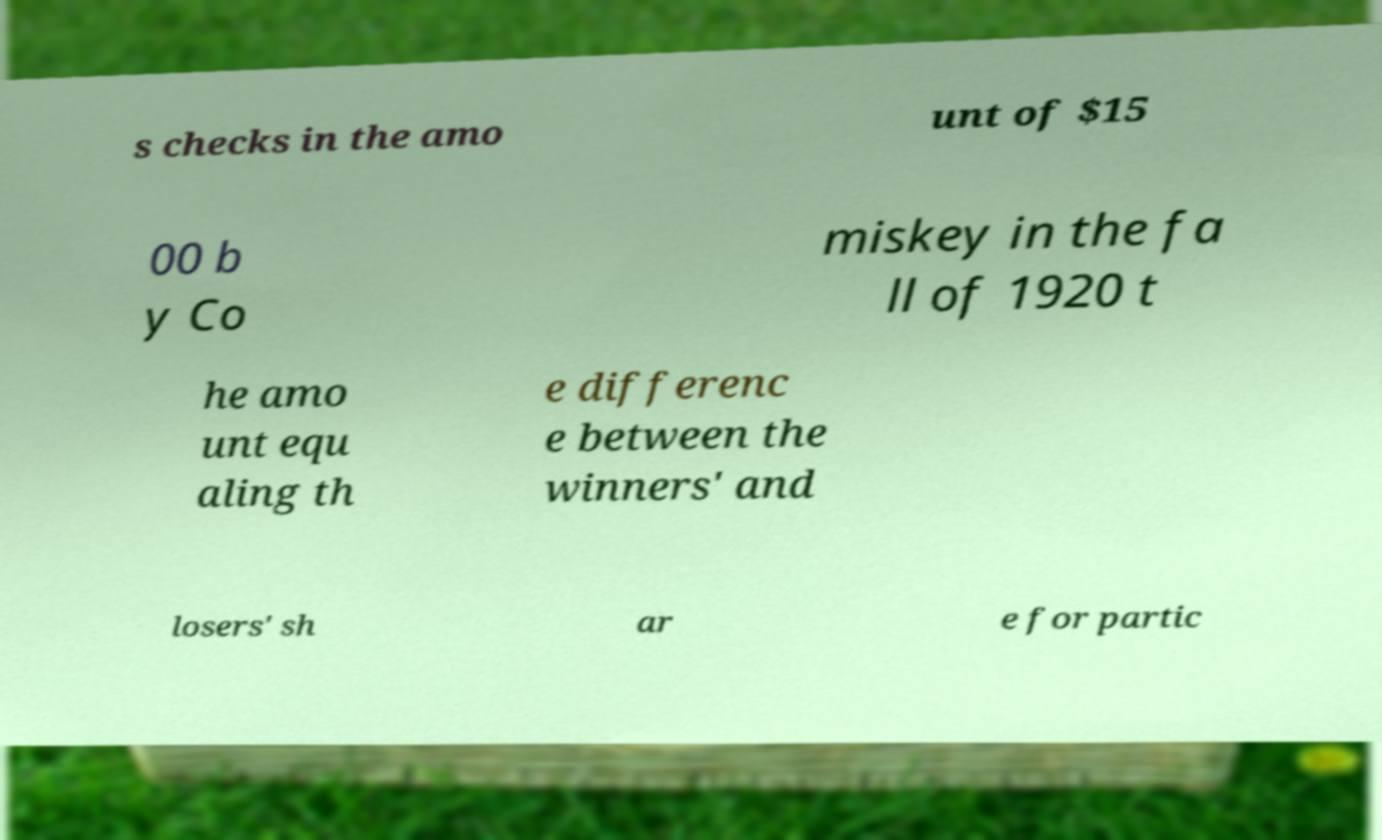There's text embedded in this image that I need extracted. Can you transcribe it verbatim? s checks in the amo unt of $15 00 b y Co miskey in the fa ll of 1920 t he amo unt equ aling th e differenc e between the winners' and losers' sh ar e for partic 